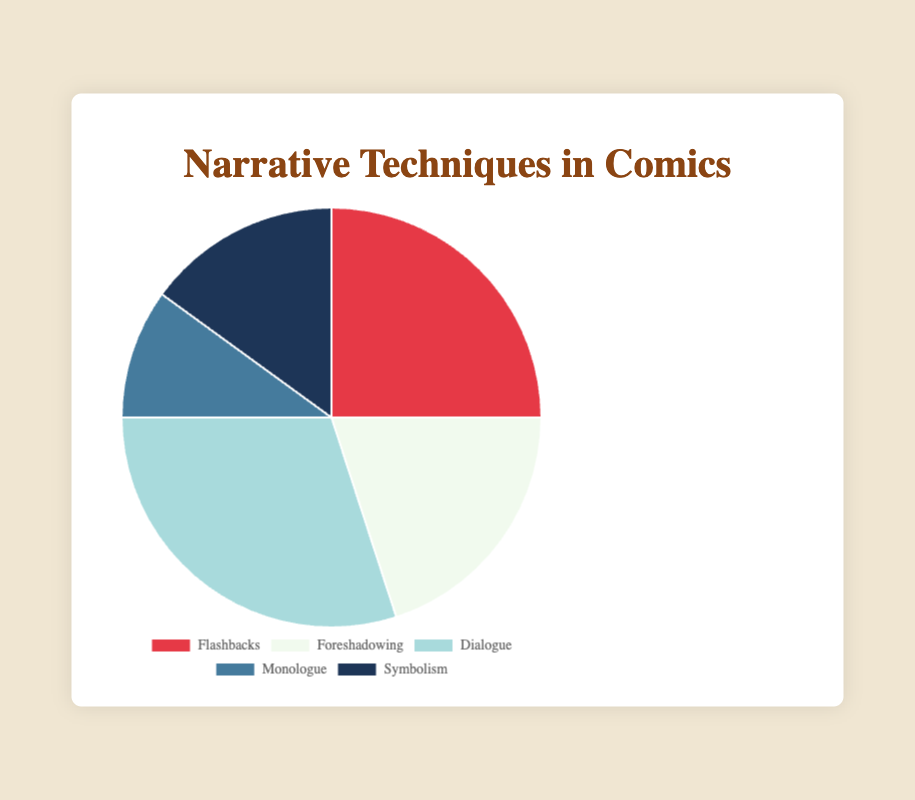What is the predominant narrative technique used in comics according to the figure? To determine the predominant technique, look for the largest segment of the pie chart. The largest segment is for "Dialogue" with 30%.
Answer: Dialogue Which narrative technique is least used in comics? To find the least used technique, look for the smallest segment of the pie chart. The smallest segment represents "Monologue" with 10%.
Answer: Monologue How many narrative techniques have a percentage greater than 20%? Analyze each segment of the pie chart: "Flashbacks" has 25%, "Foreshadowing" has 20%, "Dialogue" has 30%, "Monologue" has 10%, and "Symbolism" has 15%. Only "Flashbacks" and "Dialogue" have greater than 20%.
Answer: 2 What is the total percentage of narrative techniques related to verbal elements (Dialogue and Monologue)? Add the percentages of "Dialogue" and "Monologue." "Dialogue" is 30% and "Monologue" is 10%. 30% + 10% = 40%
Answer: 40% Which narrative technique has a percentage that is exactly 5% lower than the technique with the highest percentage? The technique with the highest percentage is "Dialogue" with 30%. 5% lower than 30% is 25%. "Flashbacks" is the technique with 25%.
Answer: Flashbacks Which technique has a percentage less than half of the "Flashbacks"? "Flashbacks" has 25%. Half of 25% is 12.5%. The only technique with a percentage less than 12.5% is "Monologue" with 10%.
Answer: Monologue If you sum the percentages of "Symbolism" and "Foreshadowing," will it be greater than or less than the percentage of "Dialogue"? "Symbolism" is 15% and "Foreshadowing" is 20%. 15% + 20% = 35%. "Dialogue" is 30%. Therefore, 35% is greater than 30%.
Answer: Greater Identify the technique associated with the color blue in the chart. By observing the colors used in the pie chart and corresponding technique:
- "Dialogue" is represented by the color blue.
Answer: Dialogue 